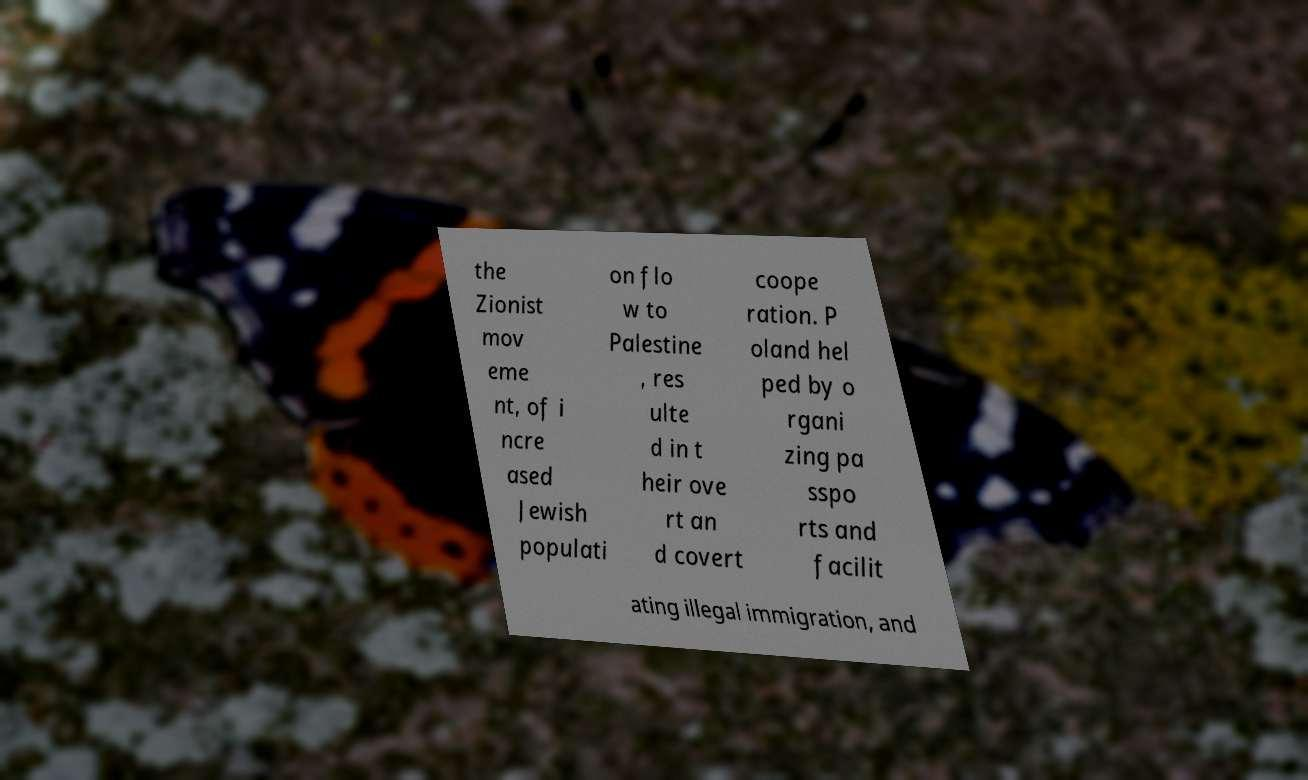Can you read and provide the text displayed in the image?This photo seems to have some interesting text. Can you extract and type it out for me? the Zionist mov eme nt, of i ncre ased Jewish populati on flo w to Palestine , res ulte d in t heir ove rt an d covert coope ration. P oland hel ped by o rgani zing pa sspo rts and facilit ating illegal immigration, and 